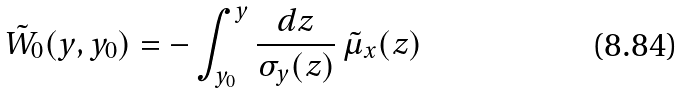<formula> <loc_0><loc_0><loc_500><loc_500>\tilde { W } _ { 0 } ( y , y _ { 0 } ) = - \int _ { y _ { 0 } } ^ { y } \frac { d z } { \sigma _ { y } ( z ) } \, \tilde { \mu } _ { x } ( z ) \\</formula> 